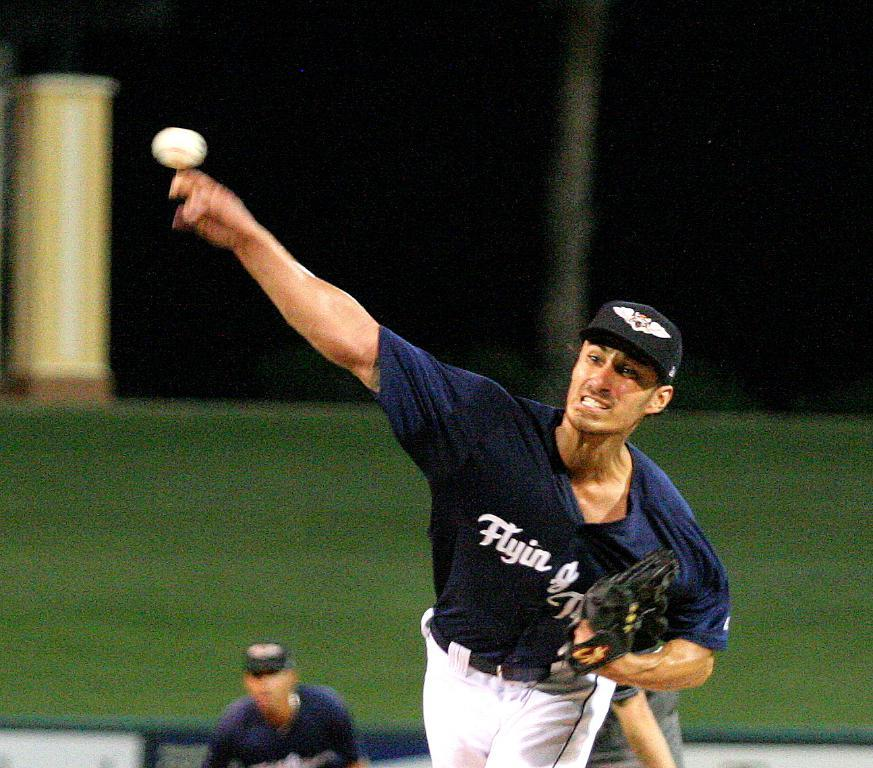<image>
Share a concise interpretation of the image provided. A pitcher wearing a t-shirt with the word flyin on it releases a pitch. 